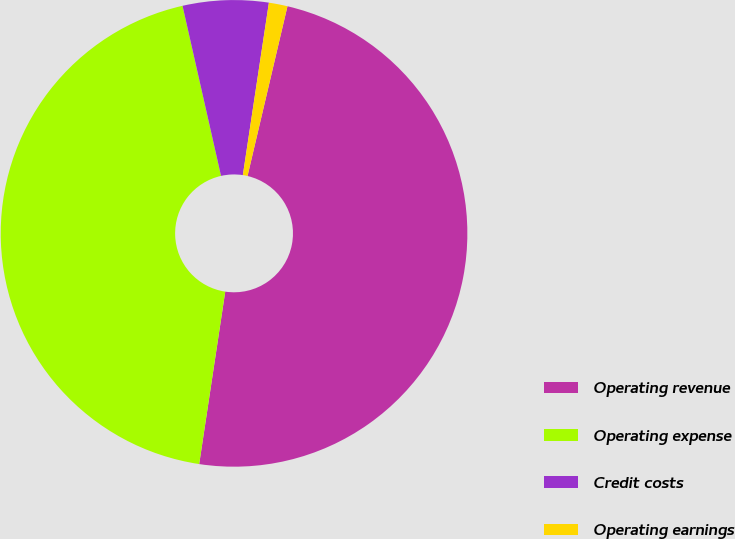Convert chart to OTSL. <chart><loc_0><loc_0><loc_500><loc_500><pie_chart><fcel>Operating revenue<fcel>Operating expense<fcel>Credit costs<fcel>Operating earnings<nl><fcel>48.71%<fcel>44.07%<fcel>5.93%<fcel>1.29%<nl></chart> 